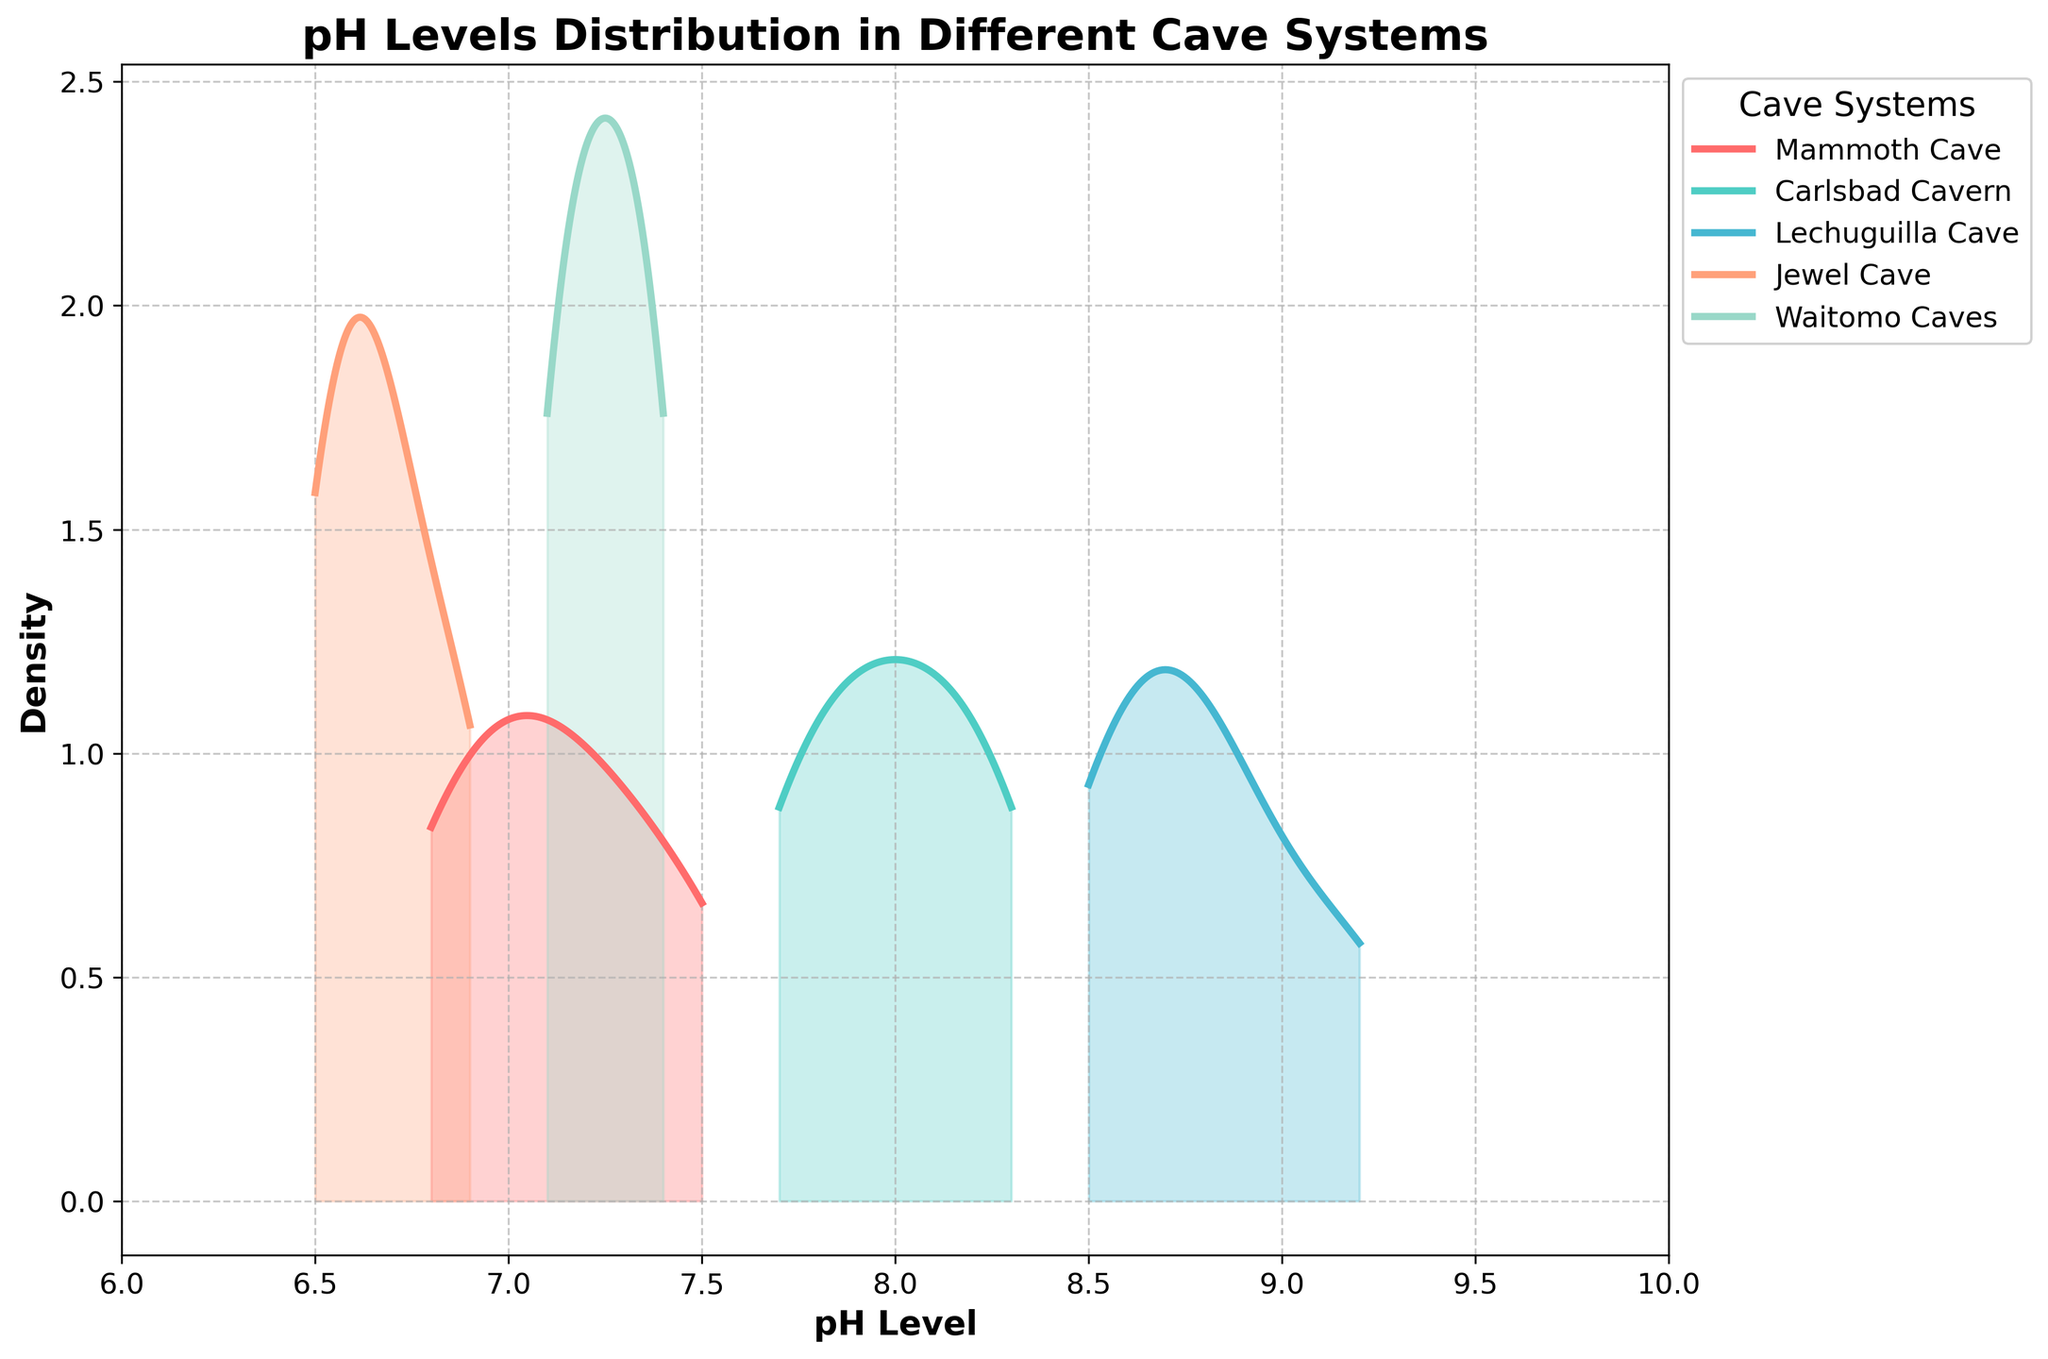What is the title of the figure? The title of the figure is located at the top, indicating what the data visualization represents. Based on the configuration in the code, the title reads "pH Levels Distribution in Different Cave Systems".
Answer: pH Levels Distribution in Different Cave Systems What is the pH range that the x-axis covers? The x-axis of a density plot shows the range of values being analyzed, and in this case, it is the pH levels. According to the setup, it spans from 6 to 10.
Answer: 6 to 10 Which cave system has the highest peak density in pH levels? To find the cave system with the highest peak density, observe the relative heights of the density curves. The highest peak should belong to the curve with the maximum y-value.
Answer: Lechuguilla Cave What is the pH value where Lechuguilla Cave's density curve peaks? Identify the highest point of the density curve corresponding to Lechuguilla Cave, then trace vertically down to the x-axis. The Lechuguilla Cave density curve peaks at around a pH level of 8.7.
Answer: Approximately 8.7 Which cave system shows the most variation in pH levels? Variation in pH levels can be observed by looking at the spread or width of the density curves. A wider distribution indicates more variation. The Mammoth Cave system has the widest spread of density.
Answer: Mammoth Cave Compare the pH levels of Mammoth Cave and Carlsbad Cavern. Which system has higher pH levels on average? By comparing the centers of the density curves of these two caves, the Carlsbad Cavern shows higher pH levels on average than Mammoth Cave.
Answer: Carlsbad Cavern Which cave systems have overlapping pH ranges? Identify the density curves that overlap each other horizontally within the pH range, Mammoth Cave, Waitomo Caves, and Jewel Cave seem to have overlapping pH ranges.
Answer: Mammoth Cave, Waitomo Caves, Jewel Cave Between which two cave systems is the difference in peak pH most significant? Compare the highest peaks of each cave system's density curves to determine the greatest difference in their peak pH values. Lechuguilla Cave peaks around 8.7-9.2, while Jewel Cave peaks around 6.5-6.9, making them most significantly different.
Answer: Lechuguilla Cave and Jewel Cave What pH levels encompass at least one peak in the density curves? Examine the x-axis range covered by the peaks in all density curves, which lie within the range of approximately 6.5 to 9.2.
Answer: 6.5 to 9.2 Which cave system's pH levels are closest to neutral (pH 7)? Identify the density curve nearest to the pH level of 7 on the x-axis, which corresponds to the Waitomo Caves and Mammoth Cave systems.
Answer: Waitomo Caves, Mammoth Cave 